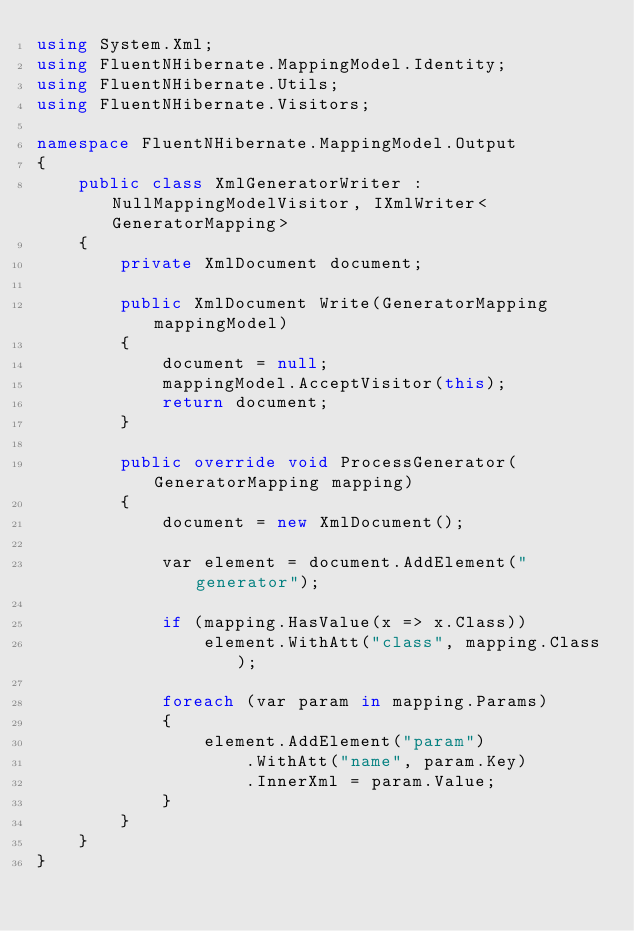Convert code to text. <code><loc_0><loc_0><loc_500><loc_500><_C#_>using System.Xml;
using FluentNHibernate.MappingModel.Identity;
using FluentNHibernate.Utils;
using FluentNHibernate.Visitors;

namespace FluentNHibernate.MappingModel.Output
{
    public class XmlGeneratorWriter : NullMappingModelVisitor, IXmlWriter<GeneratorMapping>
    {
        private XmlDocument document;

        public XmlDocument Write(GeneratorMapping mappingModel)
        {
            document = null;
            mappingModel.AcceptVisitor(this);
            return document;
        }

        public override void ProcessGenerator(GeneratorMapping mapping)
        {
            document = new XmlDocument();

            var element = document.AddElement("generator");

            if (mapping.HasValue(x => x.Class))
                element.WithAtt("class", mapping.Class);

            foreach (var param in mapping.Params)
            {
                element.AddElement("param")
                    .WithAtt("name", param.Key)
                    .InnerXml = param.Value;
            }
        }
    }
}</code> 